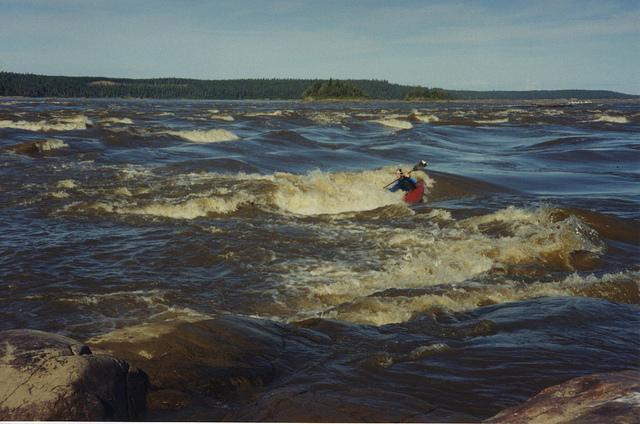How many people are in the water?
Give a very brief answer. 1. How many cats are sitting on the toilet?
Give a very brief answer. 0. 